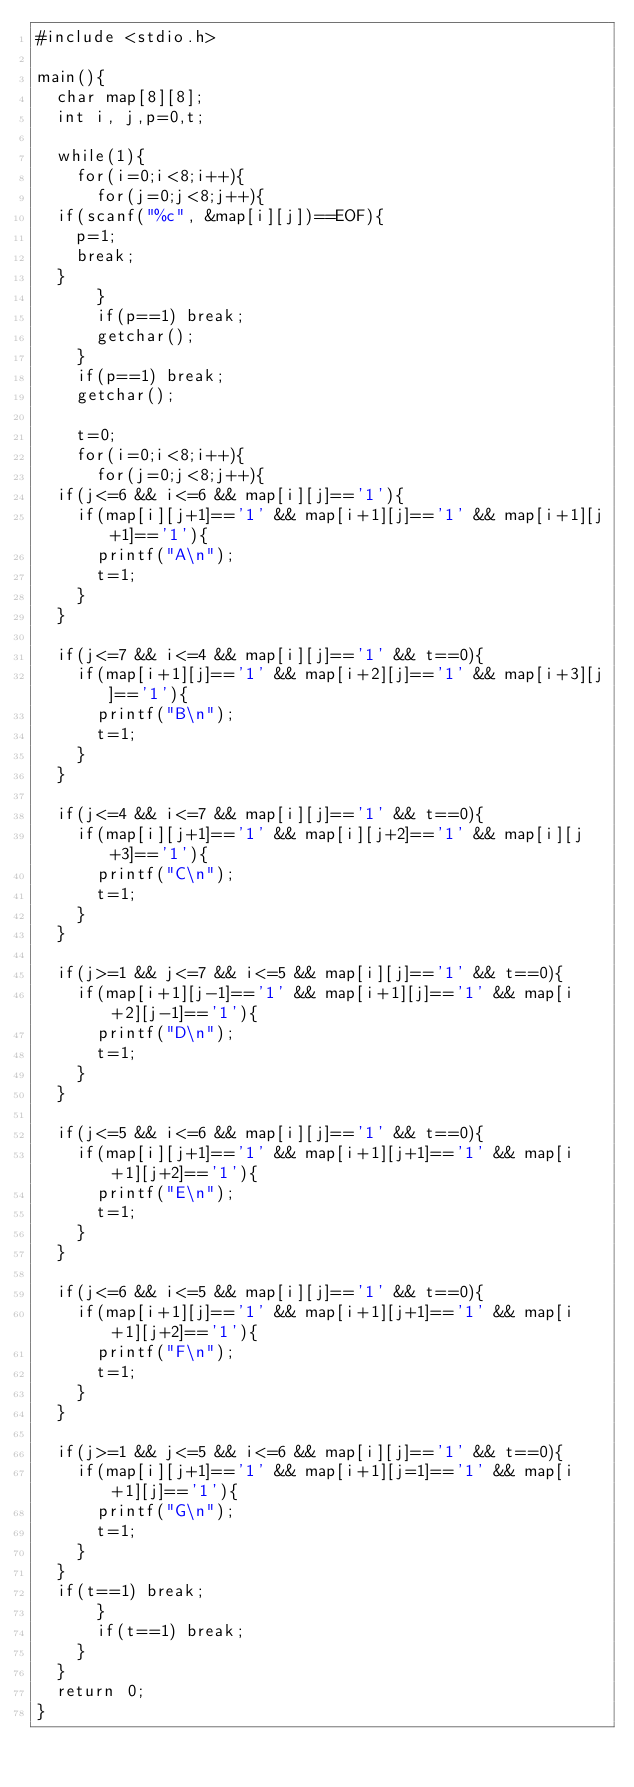<code> <loc_0><loc_0><loc_500><loc_500><_C_>#include <stdio.h>

main(){
  char map[8][8];
  int i, j,p=0,t;

  while(1){
    for(i=0;i<8;i++){
      for(j=0;j<8;j++){
	if(scanf("%c", &map[i][j])==EOF){
	  p=1;
	  break;
	}
      }
      if(p==1) break;
      getchar();
    }
    if(p==1) break;
    getchar();
    
    t=0;
    for(i=0;i<8;i++){
      for(j=0;j<8;j++){
	if(j<=6 && i<=6 && map[i][j]=='1'){
	  if(map[i][j+1]=='1' && map[i+1][j]=='1' && map[i+1][j+1]=='1'){
	    printf("A\n");
	    t=1;
	  }
	}
	
	if(j<=7 && i<=4 && map[i][j]=='1' && t==0){
	  if(map[i+1][j]=='1' && map[i+2][j]=='1' && map[i+3][j]=='1'){
	    printf("B\n");
	    t=1;
	  }
	}

	if(j<=4 && i<=7 && map[i][j]=='1' && t==0){
	  if(map[i][j+1]=='1' && map[i][j+2]=='1' && map[i][j+3]=='1'){
	    printf("C\n");
	    t=1;
	  }
	}

	if(j>=1 && j<=7 && i<=5 && map[i][j]=='1' && t==0){
	  if(map[i+1][j-1]=='1' && map[i+1][j]=='1' && map[i+2][j-1]=='1'){
	    printf("D\n");
	    t=1;
	  }
	}

	if(j<=5 && i<=6 && map[i][j]=='1' && t==0){
	  if(map[i][j+1]=='1' && map[i+1][j+1]=='1' && map[i+1][j+2]=='1'){
	    printf("E\n");
	    t=1;
	  }
	}

	if(j<=6 && i<=5 && map[i][j]=='1' && t==0){
	  if(map[i+1][j]=='1' && map[i+1][j+1]=='1' && map[i+1][j+2]=='1'){
	    printf("F\n");
	    t=1;
	  }
	}

	if(j>=1 && j<=5 && i<=6 && map[i][j]=='1' && t==0){
	  if(map[i][j+1]=='1' && map[i+1][j=1]=='1' && map[i+1][j]=='1'){
	    printf("G\n");
	    t=1;
	  }
	}
	if(t==1) break;
      }
      if(t==1) break;
    }
  }
  return 0;
}</code> 